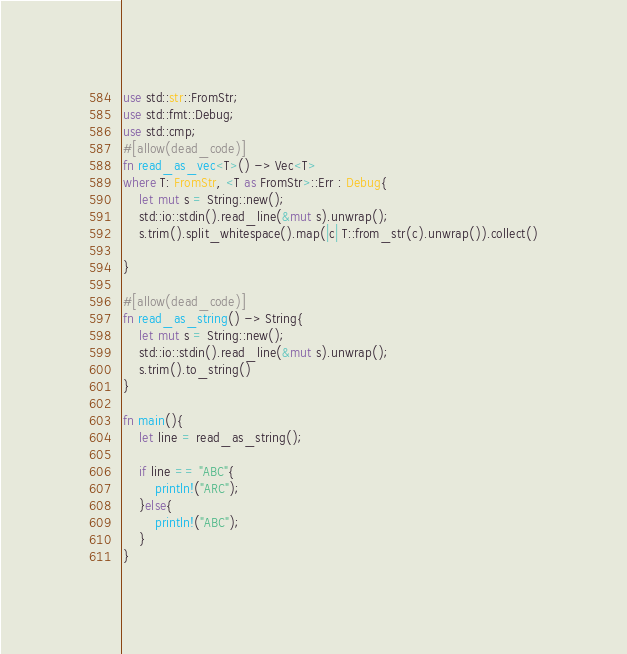Convert code to text. <code><loc_0><loc_0><loc_500><loc_500><_Rust_>use std::str::FromStr;
use std::fmt::Debug;
use std::cmp;
#[allow(dead_code)]
fn read_as_vec<T>() -> Vec<T>
where T: FromStr, <T as FromStr>::Err : Debug{
    let mut s = String::new();
    std::io::stdin().read_line(&mut s).unwrap();
    s.trim().split_whitespace().map(|c| T::from_str(c).unwrap()).collect()

}

#[allow(dead_code)]
fn read_as_string() -> String{
    let mut s = String::new();
    std::io::stdin().read_line(&mut s).unwrap();
    s.trim().to_string()
}

fn main(){
    let line = read_as_string();

    if line == "ABC"{
        println!("ARC");
    }else{
        println!("ABC");
    }
}
</code> 